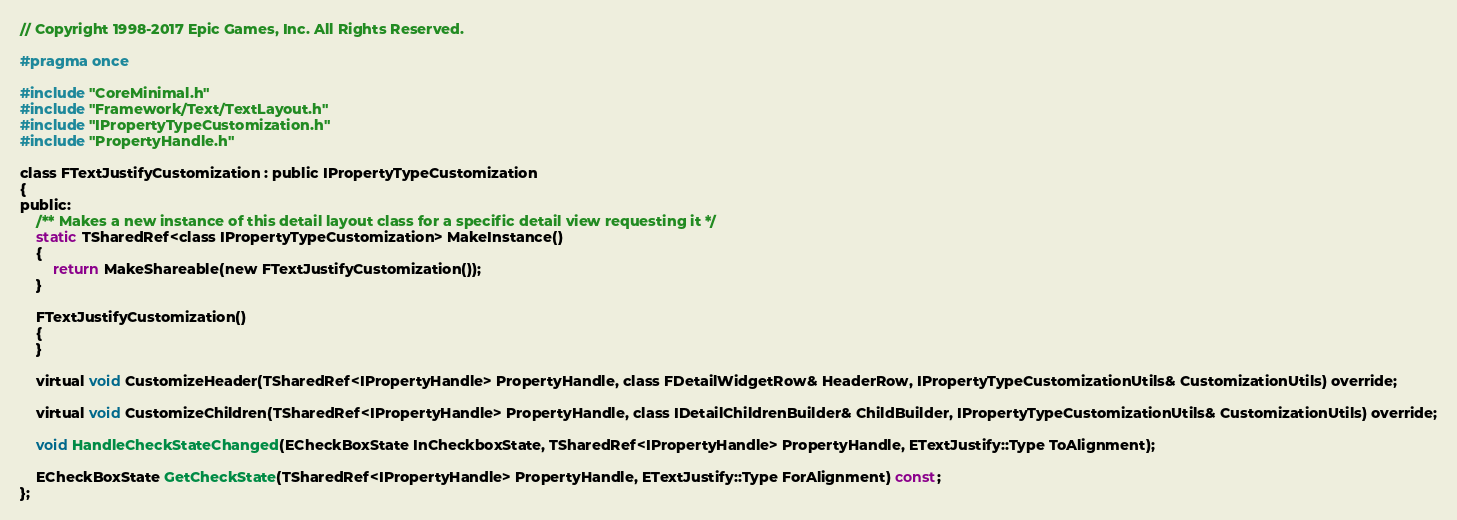<code> <loc_0><loc_0><loc_500><loc_500><_C_>// Copyright 1998-2017 Epic Games, Inc. All Rights Reserved.

#pragma once

#include "CoreMinimal.h"
#include "Framework/Text/TextLayout.h"
#include "IPropertyTypeCustomization.h"
#include "PropertyHandle.h"

class FTextJustifyCustomization : public IPropertyTypeCustomization
{
public:
	/** Makes a new instance of this detail layout class for a specific detail view requesting it */
	static TSharedRef<class IPropertyTypeCustomization> MakeInstance()
	{
		return MakeShareable(new FTextJustifyCustomization());
	}

	FTextJustifyCustomization()
	{
	}
	
	virtual void CustomizeHeader(TSharedRef<IPropertyHandle> PropertyHandle, class FDetailWidgetRow& HeaderRow, IPropertyTypeCustomizationUtils& CustomizationUtils) override;

	virtual void CustomizeChildren(TSharedRef<IPropertyHandle> PropertyHandle, class IDetailChildrenBuilder& ChildBuilder, IPropertyTypeCustomizationUtils& CustomizationUtils) override;
	
	void HandleCheckStateChanged(ECheckBoxState InCheckboxState, TSharedRef<IPropertyHandle> PropertyHandle, ETextJustify::Type ToAlignment);

	ECheckBoxState GetCheckState(TSharedRef<IPropertyHandle> PropertyHandle, ETextJustify::Type ForAlignment) const;
};
</code> 